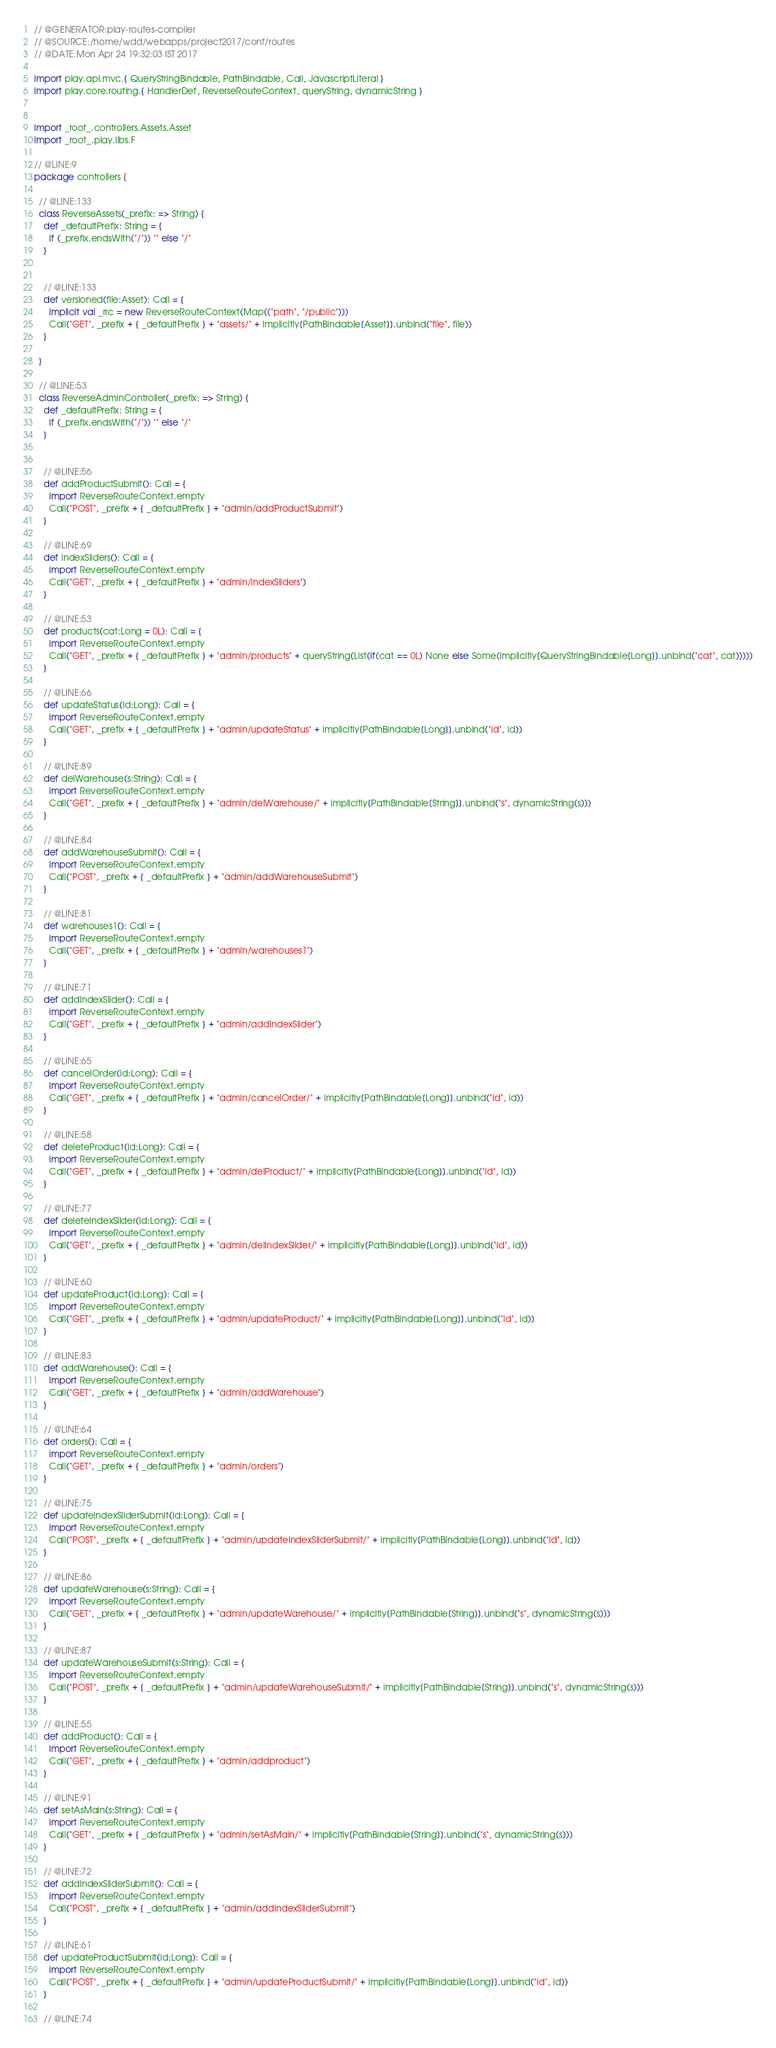<code> <loc_0><loc_0><loc_500><loc_500><_Scala_>
// @GENERATOR:play-routes-compiler
// @SOURCE:/home/wdd/webapps/project2017/conf/routes
// @DATE:Mon Apr 24 19:32:03 IST 2017

import play.api.mvc.{ QueryStringBindable, PathBindable, Call, JavascriptLiteral }
import play.core.routing.{ HandlerDef, ReverseRouteContext, queryString, dynamicString }


import _root_.controllers.Assets.Asset
import _root_.play.libs.F

// @LINE:9
package controllers {

  // @LINE:133
  class ReverseAssets(_prefix: => String) {
    def _defaultPrefix: String = {
      if (_prefix.endsWith("/")) "" else "/"
    }

  
    // @LINE:133
    def versioned(file:Asset): Call = {
      implicit val _rrc = new ReverseRouteContext(Map(("path", "/public")))
      Call("GET", _prefix + { _defaultPrefix } + "assets/" + implicitly[PathBindable[Asset]].unbind("file", file))
    }
  
  }

  // @LINE:53
  class ReverseAdminController(_prefix: => String) {
    def _defaultPrefix: String = {
      if (_prefix.endsWith("/")) "" else "/"
    }

  
    // @LINE:56
    def addProductSubmit(): Call = {
      import ReverseRouteContext.empty
      Call("POST", _prefix + { _defaultPrefix } + "admin/addProductSubmit")
    }
  
    // @LINE:69
    def indexSliders(): Call = {
      import ReverseRouteContext.empty
      Call("GET", _prefix + { _defaultPrefix } + "admin/indexSliders")
    }
  
    // @LINE:53
    def products(cat:Long = 0L): Call = {
      import ReverseRouteContext.empty
      Call("GET", _prefix + { _defaultPrefix } + "admin/products" + queryString(List(if(cat == 0L) None else Some(implicitly[QueryStringBindable[Long]].unbind("cat", cat)))))
    }
  
    // @LINE:66
    def updateStatus(id:Long): Call = {
      import ReverseRouteContext.empty
      Call("GET", _prefix + { _defaultPrefix } + "admin/updateStatus" + implicitly[PathBindable[Long]].unbind("id", id))
    }
  
    // @LINE:89
    def delWarehouse(s:String): Call = {
      import ReverseRouteContext.empty
      Call("GET", _prefix + { _defaultPrefix } + "admin/delWarehouse/" + implicitly[PathBindable[String]].unbind("s", dynamicString(s)))
    }
  
    // @LINE:84
    def addWarehouseSubmit(): Call = {
      import ReverseRouteContext.empty
      Call("POST", _prefix + { _defaultPrefix } + "admin/addWarehouseSubmit")
    }
  
    // @LINE:81
    def warehouses1(): Call = {
      import ReverseRouteContext.empty
      Call("GET", _prefix + { _defaultPrefix } + "admin/warehouses1")
    }
  
    // @LINE:71
    def addIndexSlider(): Call = {
      import ReverseRouteContext.empty
      Call("GET", _prefix + { _defaultPrefix } + "admin/addIndexSlider")
    }
  
    // @LINE:65
    def cancelOrder(id:Long): Call = {
      import ReverseRouteContext.empty
      Call("GET", _prefix + { _defaultPrefix } + "admin/cancelOrder/" + implicitly[PathBindable[Long]].unbind("id", id))
    }
  
    // @LINE:58
    def deleteProduct(id:Long): Call = {
      import ReverseRouteContext.empty
      Call("GET", _prefix + { _defaultPrefix } + "admin/delProduct/" + implicitly[PathBindable[Long]].unbind("id", id))
    }
  
    // @LINE:77
    def deleteIndexSlider(id:Long): Call = {
      import ReverseRouteContext.empty
      Call("GET", _prefix + { _defaultPrefix } + "admin/delIndexSlider/" + implicitly[PathBindable[Long]].unbind("id", id))
    }
  
    // @LINE:60
    def updateProduct(id:Long): Call = {
      import ReverseRouteContext.empty
      Call("GET", _prefix + { _defaultPrefix } + "admin/updateProduct/" + implicitly[PathBindable[Long]].unbind("id", id))
    }
  
    // @LINE:83
    def addWarehouse(): Call = {
      import ReverseRouteContext.empty
      Call("GET", _prefix + { _defaultPrefix } + "admin/addWarehouse")
    }
  
    // @LINE:64
    def orders(): Call = {
      import ReverseRouteContext.empty
      Call("GET", _prefix + { _defaultPrefix } + "admin/orders")
    }
  
    // @LINE:75
    def updateIndexSliderSubmit(id:Long): Call = {
      import ReverseRouteContext.empty
      Call("POST", _prefix + { _defaultPrefix } + "admin/updateIndexSliderSubmit/" + implicitly[PathBindable[Long]].unbind("id", id))
    }
  
    // @LINE:86
    def updateWarehouse(s:String): Call = {
      import ReverseRouteContext.empty
      Call("GET", _prefix + { _defaultPrefix } + "admin/updateWarehouse/" + implicitly[PathBindable[String]].unbind("s", dynamicString(s)))
    }
  
    // @LINE:87
    def updateWarehouseSubmit(s:String): Call = {
      import ReverseRouteContext.empty
      Call("POST", _prefix + { _defaultPrefix } + "admin/updateWarehouseSubmit/" + implicitly[PathBindable[String]].unbind("s", dynamicString(s)))
    }
  
    // @LINE:55
    def addProduct(): Call = {
      import ReverseRouteContext.empty
      Call("GET", _prefix + { _defaultPrefix } + "admin/addproduct")
    }
  
    // @LINE:91
    def setAsMain(s:String): Call = {
      import ReverseRouteContext.empty
      Call("GET", _prefix + { _defaultPrefix } + "admin/setAsMain/" + implicitly[PathBindable[String]].unbind("s", dynamicString(s)))
    }
  
    // @LINE:72
    def addIndexSliderSubmit(): Call = {
      import ReverseRouteContext.empty
      Call("POST", _prefix + { _defaultPrefix } + "admin/addIndexSliderSubmit")
    }
  
    // @LINE:61
    def updateProductSubmit(id:Long): Call = {
      import ReverseRouteContext.empty
      Call("POST", _prefix + { _defaultPrefix } + "admin/updateProductSubmit/" + implicitly[PathBindable[Long]].unbind("id", id))
    }
  
    // @LINE:74</code> 